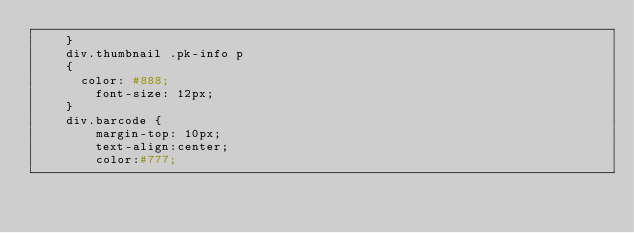Convert code to text. <code><loc_0><loc_0><loc_500><loc_500><_PHP_>    }
    div.thumbnail .pk-info p
    {
      color: #888;
        font-size: 12px;
    }
    div.barcode {
        margin-top: 10px;
        text-align:center;
        color:#777;</code> 